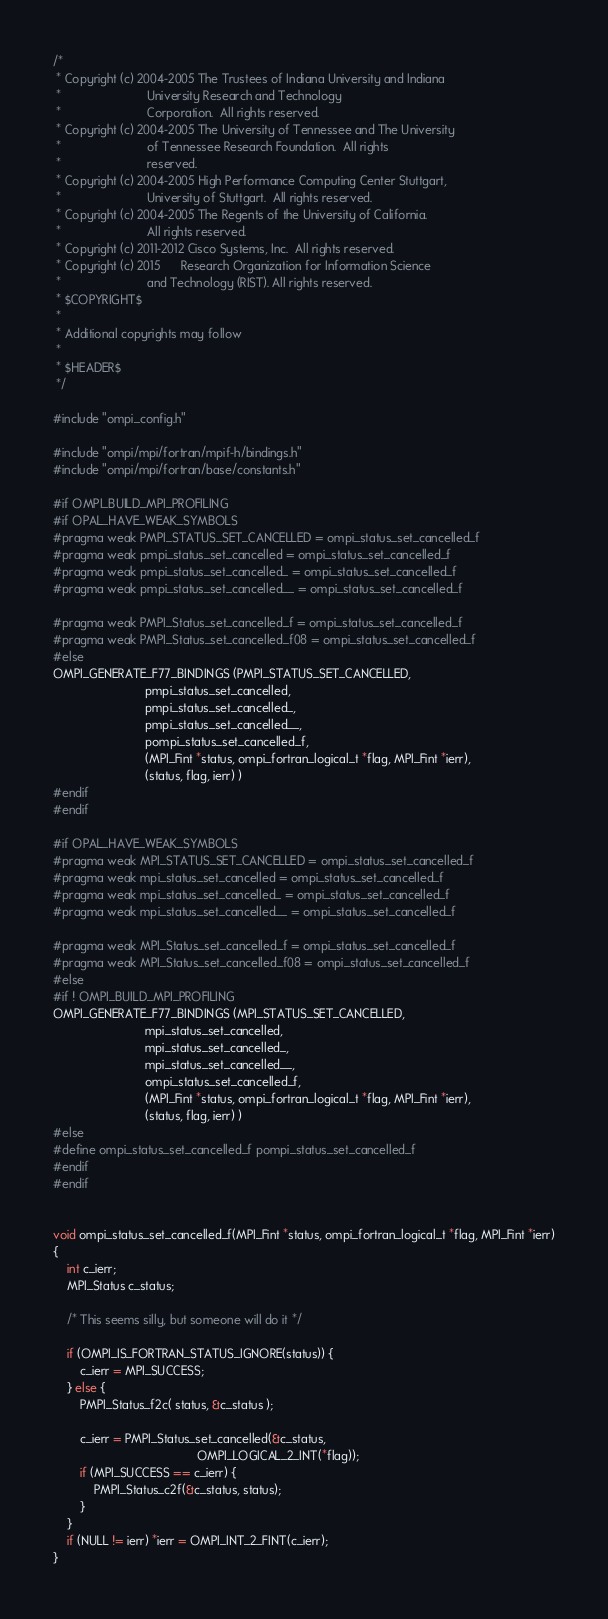Convert code to text. <code><loc_0><loc_0><loc_500><loc_500><_C_>/*
 * Copyright (c) 2004-2005 The Trustees of Indiana University and Indiana
 *                         University Research and Technology
 *                         Corporation.  All rights reserved.
 * Copyright (c) 2004-2005 The University of Tennessee and The University
 *                         of Tennessee Research Foundation.  All rights
 *                         reserved.
 * Copyright (c) 2004-2005 High Performance Computing Center Stuttgart,
 *                         University of Stuttgart.  All rights reserved.
 * Copyright (c) 2004-2005 The Regents of the University of California.
 *                         All rights reserved.
 * Copyright (c) 2011-2012 Cisco Systems, Inc.  All rights reserved.
 * Copyright (c) 2015      Research Organization for Information Science
 *                         and Technology (RIST). All rights reserved.
 * $COPYRIGHT$
 *
 * Additional copyrights may follow
 *
 * $HEADER$
 */

#include "ompi_config.h"

#include "ompi/mpi/fortran/mpif-h/bindings.h"
#include "ompi/mpi/fortran/base/constants.h"

#if OMPI_BUILD_MPI_PROFILING
#if OPAL_HAVE_WEAK_SYMBOLS
#pragma weak PMPI_STATUS_SET_CANCELLED = ompi_status_set_cancelled_f
#pragma weak pmpi_status_set_cancelled = ompi_status_set_cancelled_f
#pragma weak pmpi_status_set_cancelled_ = ompi_status_set_cancelled_f
#pragma weak pmpi_status_set_cancelled__ = ompi_status_set_cancelled_f

#pragma weak PMPI_Status_set_cancelled_f = ompi_status_set_cancelled_f
#pragma weak PMPI_Status_set_cancelled_f08 = ompi_status_set_cancelled_f
#else
OMPI_GENERATE_F77_BINDINGS (PMPI_STATUS_SET_CANCELLED,
                           pmpi_status_set_cancelled,
                           pmpi_status_set_cancelled_,
                           pmpi_status_set_cancelled__,
                           pompi_status_set_cancelled_f,
                           (MPI_Fint *status, ompi_fortran_logical_t *flag, MPI_Fint *ierr),
                           (status, flag, ierr) )
#endif
#endif

#if OPAL_HAVE_WEAK_SYMBOLS
#pragma weak MPI_STATUS_SET_CANCELLED = ompi_status_set_cancelled_f
#pragma weak mpi_status_set_cancelled = ompi_status_set_cancelled_f
#pragma weak mpi_status_set_cancelled_ = ompi_status_set_cancelled_f
#pragma weak mpi_status_set_cancelled__ = ompi_status_set_cancelled_f

#pragma weak MPI_Status_set_cancelled_f = ompi_status_set_cancelled_f
#pragma weak MPI_Status_set_cancelled_f08 = ompi_status_set_cancelled_f
#else
#if ! OMPI_BUILD_MPI_PROFILING
OMPI_GENERATE_F77_BINDINGS (MPI_STATUS_SET_CANCELLED,
                           mpi_status_set_cancelled,
                           mpi_status_set_cancelled_,
                           mpi_status_set_cancelled__,
                           ompi_status_set_cancelled_f,
                           (MPI_Fint *status, ompi_fortran_logical_t *flag, MPI_Fint *ierr),
                           (status, flag, ierr) )
#else
#define ompi_status_set_cancelled_f pompi_status_set_cancelled_f
#endif
#endif


void ompi_status_set_cancelled_f(MPI_Fint *status, ompi_fortran_logical_t *flag, MPI_Fint *ierr)
{
    int c_ierr;
    MPI_Status c_status;

    /* This seems silly, but someone will do it */

    if (OMPI_IS_FORTRAN_STATUS_IGNORE(status)) {
        c_ierr = MPI_SUCCESS;
    } else {
        PMPI_Status_f2c( status, &c_status );

        c_ierr = PMPI_Status_set_cancelled(&c_status,
                                          OMPI_LOGICAL_2_INT(*flag));
        if (MPI_SUCCESS == c_ierr) {
            PMPI_Status_c2f(&c_status, status);
        }
    }
    if (NULL != ierr) *ierr = OMPI_INT_2_FINT(c_ierr);
}
</code> 